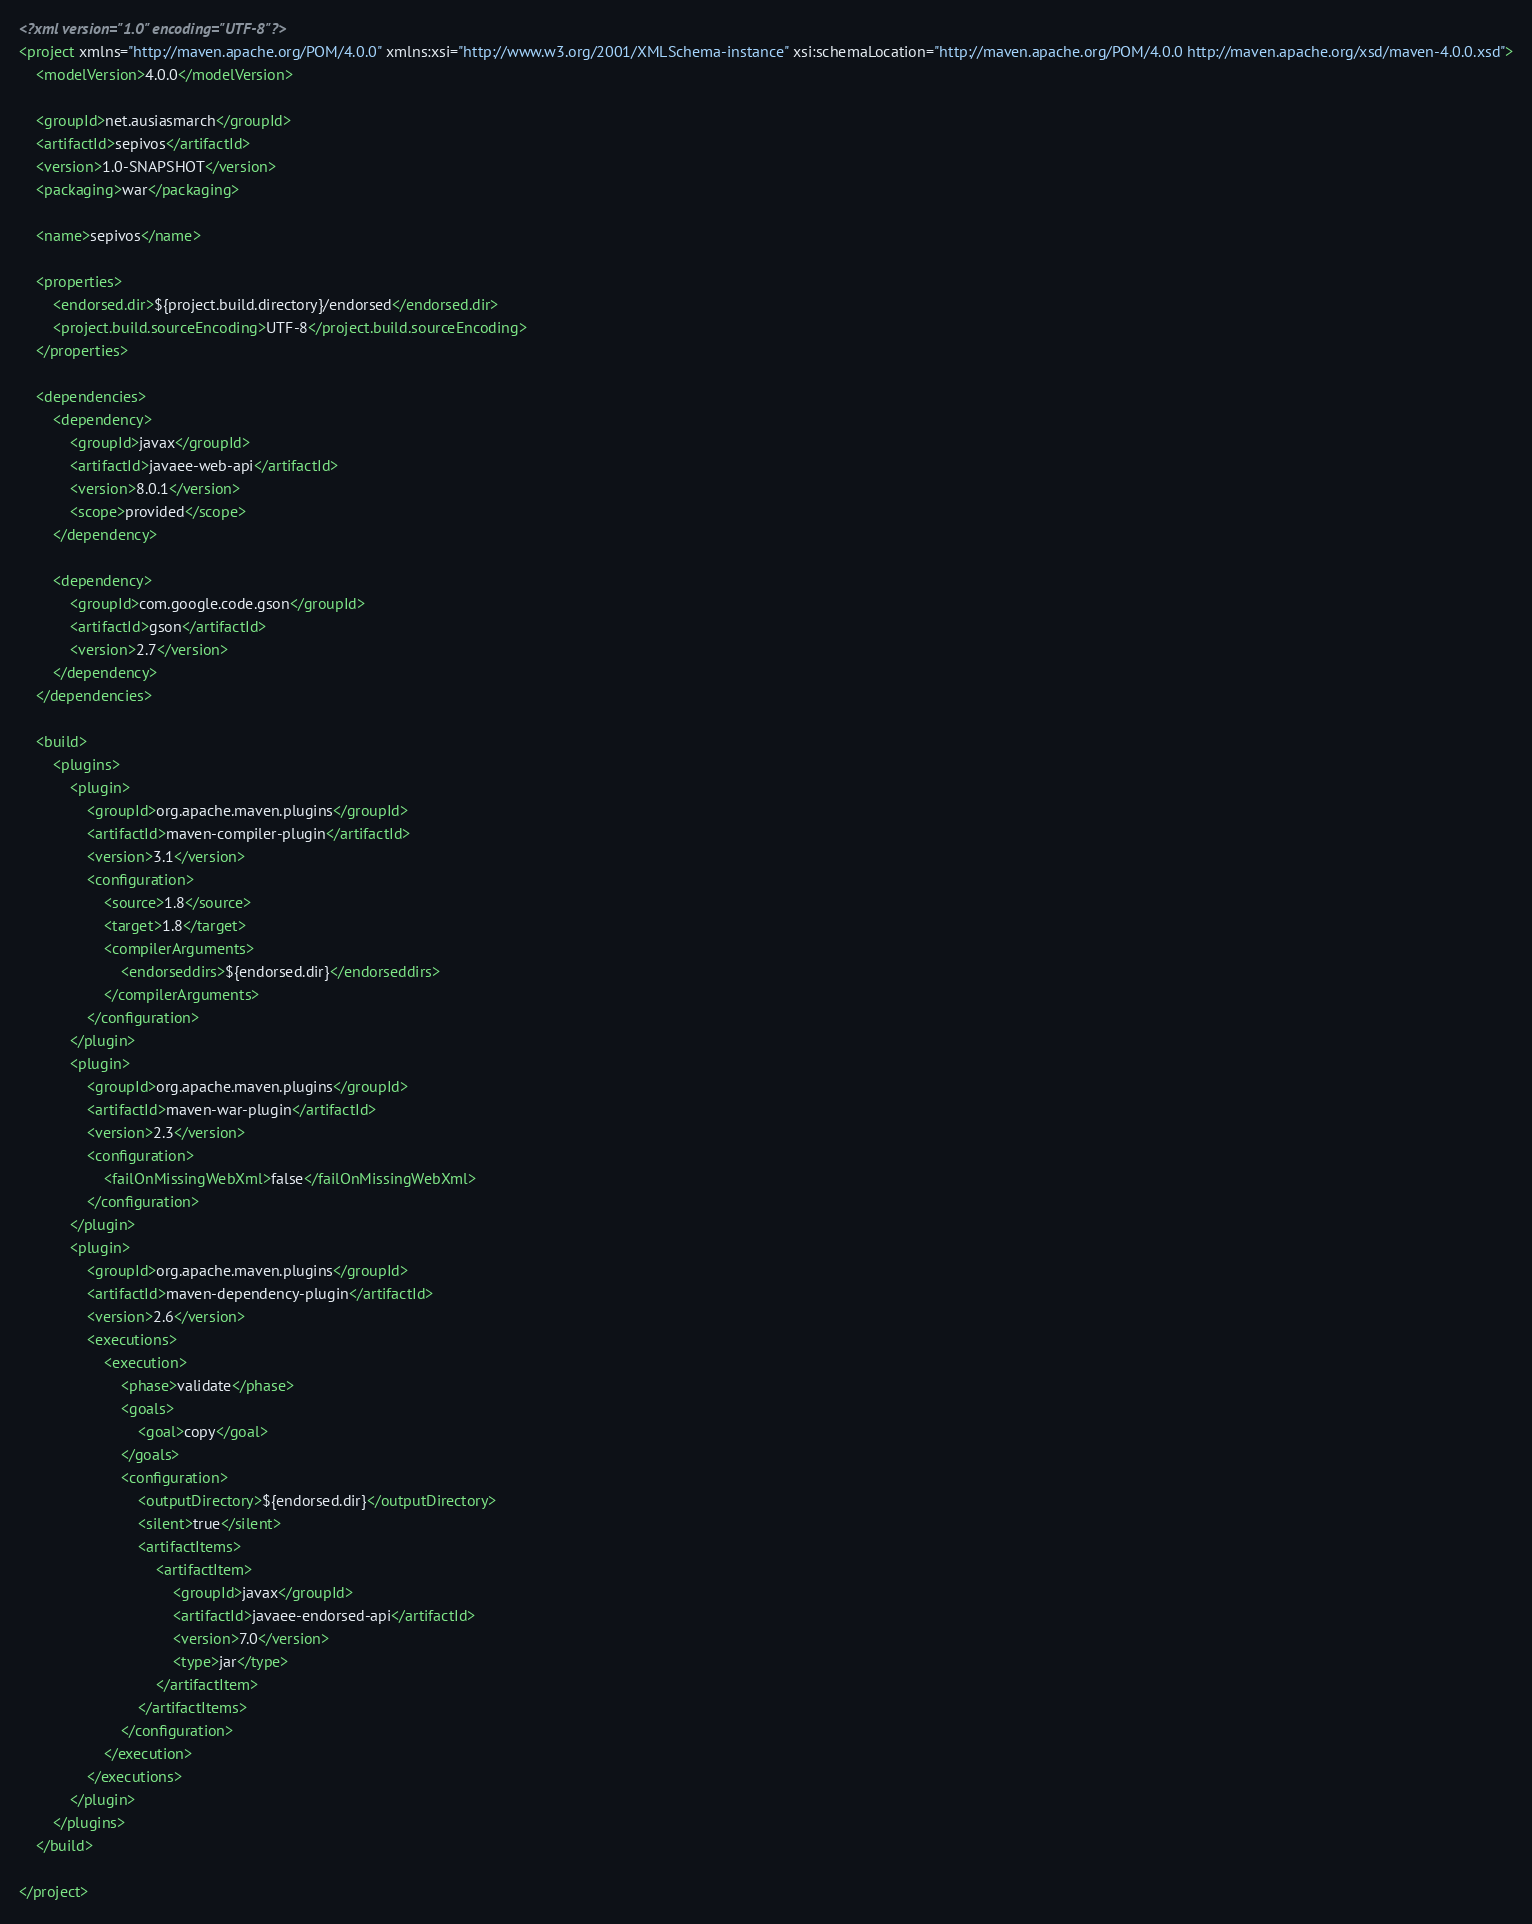<code> <loc_0><loc_0><loc_500><loc_500><_XML_><?xml version="1.0" encoding="UTF-8"?>
<project xmlns="http://maven.apache.org/POM/4.0.0" xmlns:xsi="http://www.w3.org/2001/XMLSchema-instance" xsi:schemaLocation="http://maven.apache.org/POM/4.0.0 http://maven.apache.org/xsd/maven-4.0.0.xsd">
    <modelVersion>4.0.0</modelVersion>

    <groupId>net.ausiasmarch</groupId>
    <artifactId>sepivos</artifactId>
    <version>1.0-SNAPSHOT</version>
    <packaging>war</packaging>

    <name>sepivos</name>

    <properties>
        <endorsed.dir>${project.build.directory}/endorsed</endorsed.dir>
        <project.build.sourceEncoding>UTF-8</project.build.sourceEncoding>
    </properties>
    
    <dependencies>
        <dependency>
            <groupId>javax</groupId>
            <artifactId>javaee-web-api</artifactId>
            <version>8.0.1</version>
            <scope>provided</scope>
        </dependency>
        
        <dependency>
            <groupId>com.google.code.gson</groupId>
            <artifactId>gson</artifactId>
            <version>2.7</version>
        </dependency>
    </dependencies>

    <build>
        <plugins>
            <plugin>
                <groupId>org.apache.maven.plugins</groupId>
                <artifactId>maven-compiler-plugin</artifactId>
                <version>3.1</version>
                <configuration>
                    <source>1.8</source>
                    <target>1.8</target>
                    <compilerArguments>
                        <endorseddirs>${endorsed.dir}</endorseddirs>
                    </compilerArguments>
                </configuration>
            </plugin>
            <plugin>
                <groupId>org.apache.maven.plugins</groupId>
                <artifactId>maven-war-plugin</artifactId>
                <version>2.3</version>
                <configuration>
                    <failOnMissingWebXml>false</failOnMissingWebXml>
                </configuration>
            </plugin>
            <plugin>
                <groupId>org.apache.maven.plugins</groupId>
                <artifactId>maven-dependency-plugin</artifactId>
                <version>2.6</version>
                <executions>
                    <execution>
                        <phase>validate</phase>
                        <goals>
                            <goal>copy</goal>
                        </goals>
                        <configuration>
                            <outputDirectory>${endorsed.dir}</outputDirectory>
                            <silent>true</silent>
                            <artifactItems>
                                <artifactItem>
                                    <groupId>javax</groupId>
                                    <artifactId>javaee-endorsed-api</artifactId>
                                    <version>7.0</version>
                                    <type>jar</type>
                                </artifactItem>
                            </artifactItems>
                        </configuration>
                    </execution>
                </executions>
            </plugin>
        </plugins>
    </build>

</project>
</code> 